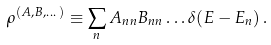Convert formula to latex. <formula><loc_0><loc_0><loc_500><loc_500>\rho ^ { ( A , B , \dots ) } \equiv \sum _ { n } A _ { n n } B _ { n n } \dots \delta ( E - E _ { n } ) \, .</formula> 